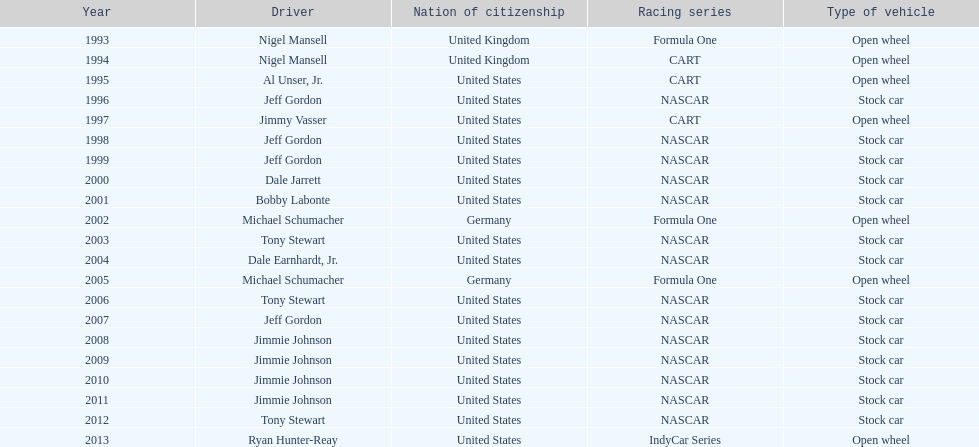Out of these drivers: nigel mansell, al unser, jr., michael schumacher, and jeff gordon, all but one has more than one espy award. who only has one espy award? Al Unser, Jr. 